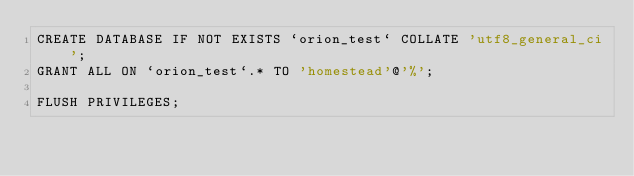Convert code to text. <code><loc_0><loc_0><loc_500><loc_500><_SQL_>CREATE DATABASE IF NOT EXISTS `orion_test` COLLATE 'utf8_general_ci';
GRANT ALL ON `orion_test`.* TO 'homestead'@'%';

FLUSH PRIVILEGES;
</code> 